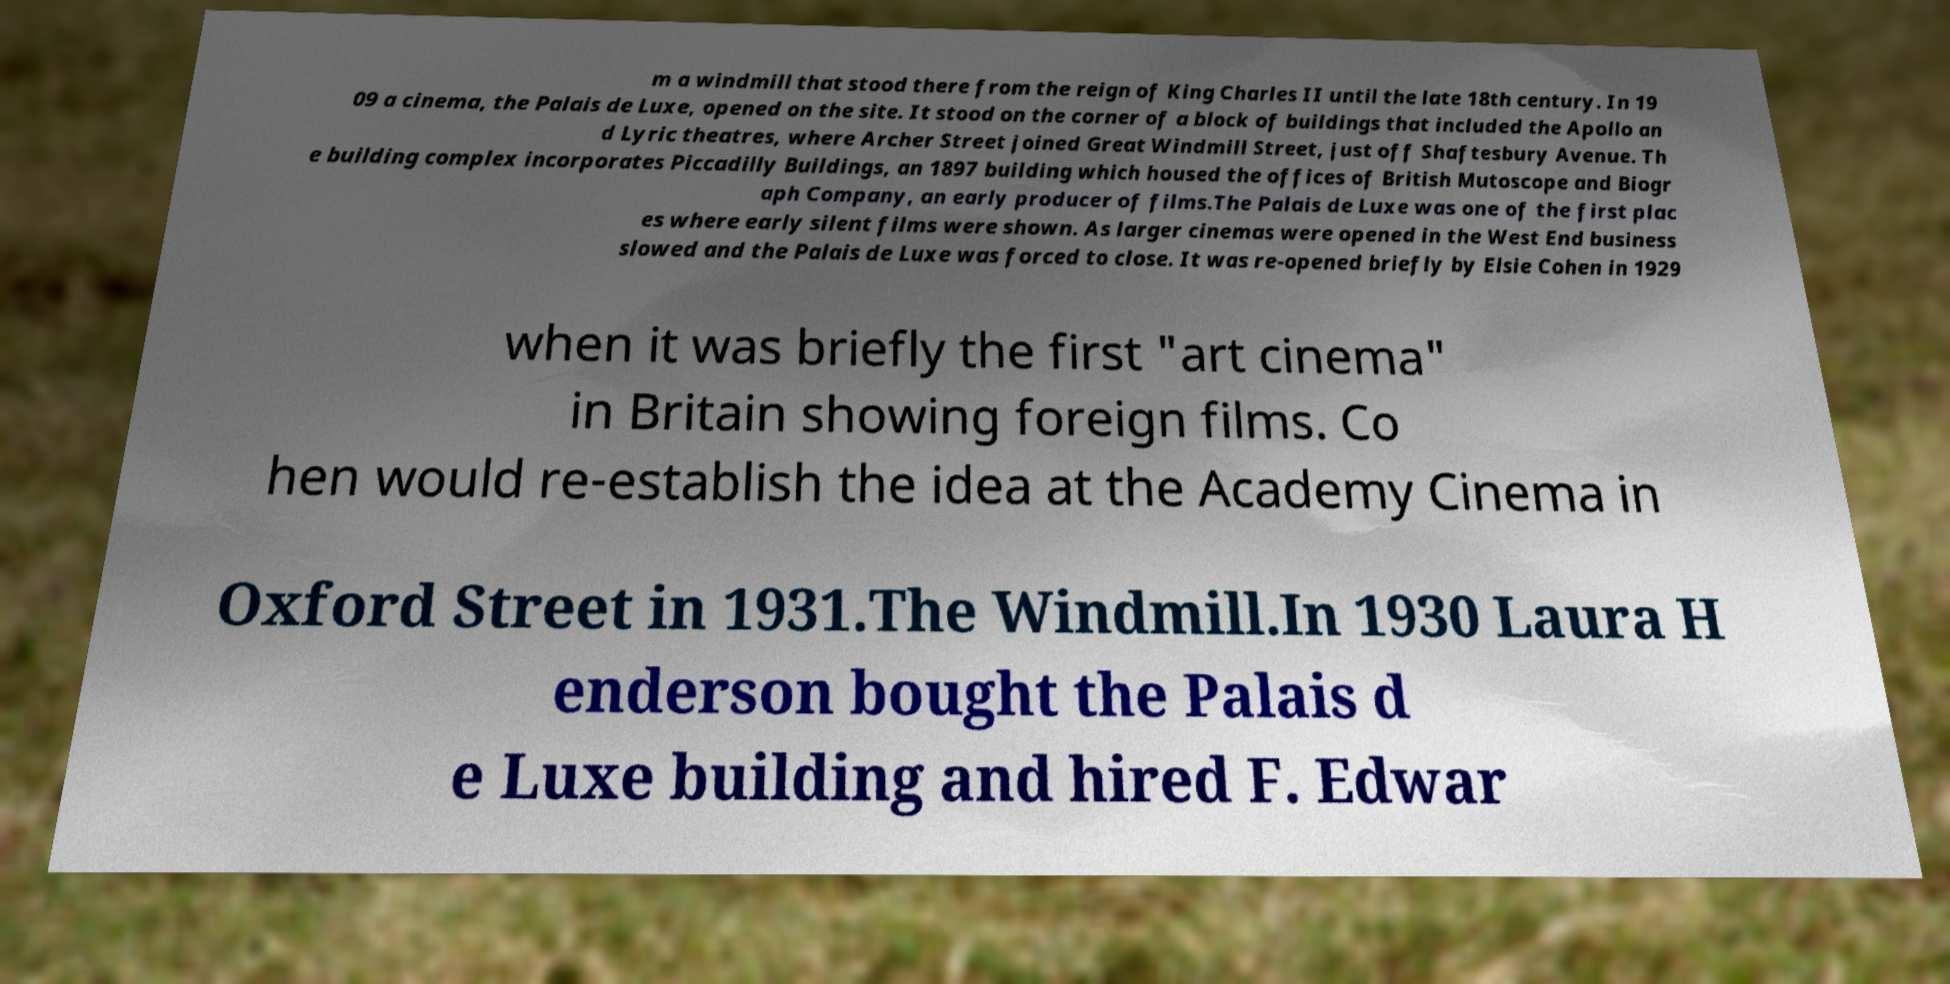Could you extract and type out the text from this image? m a windmill that stood there from the reign of King Charles II until the late 18th century. In 19 09 a cinema, the Palais de Luxe, opened on the site. It stood on the corner of a block of buildings that included the Apollo an d Lyric theatres, where Archer Street joined Great Windmill Street, just off Shaftesbury Avenue. Th e building complex incorporates Piccadilly Buildings, an 1897 building which housed the offices of British Mutoscope and Biogr aph Company, an early producer of films.The Palais de Luxe was one of the first plac es where early silent films were shown. As larger cinemas were opened in the West End business slowed and the Palais de Luxe was forced to close. It was re-opened briefly by Elsie Cohen in 1929 when it was briefly the first "art cinema" in Britain showing foreign films. Co hen would re-establish the idea at the Academy Cinema in Oxford Street in 1931.The Windmill.In 1930 Laura H enderson bought the Palais d e Luxe building and hired F. Edwar 